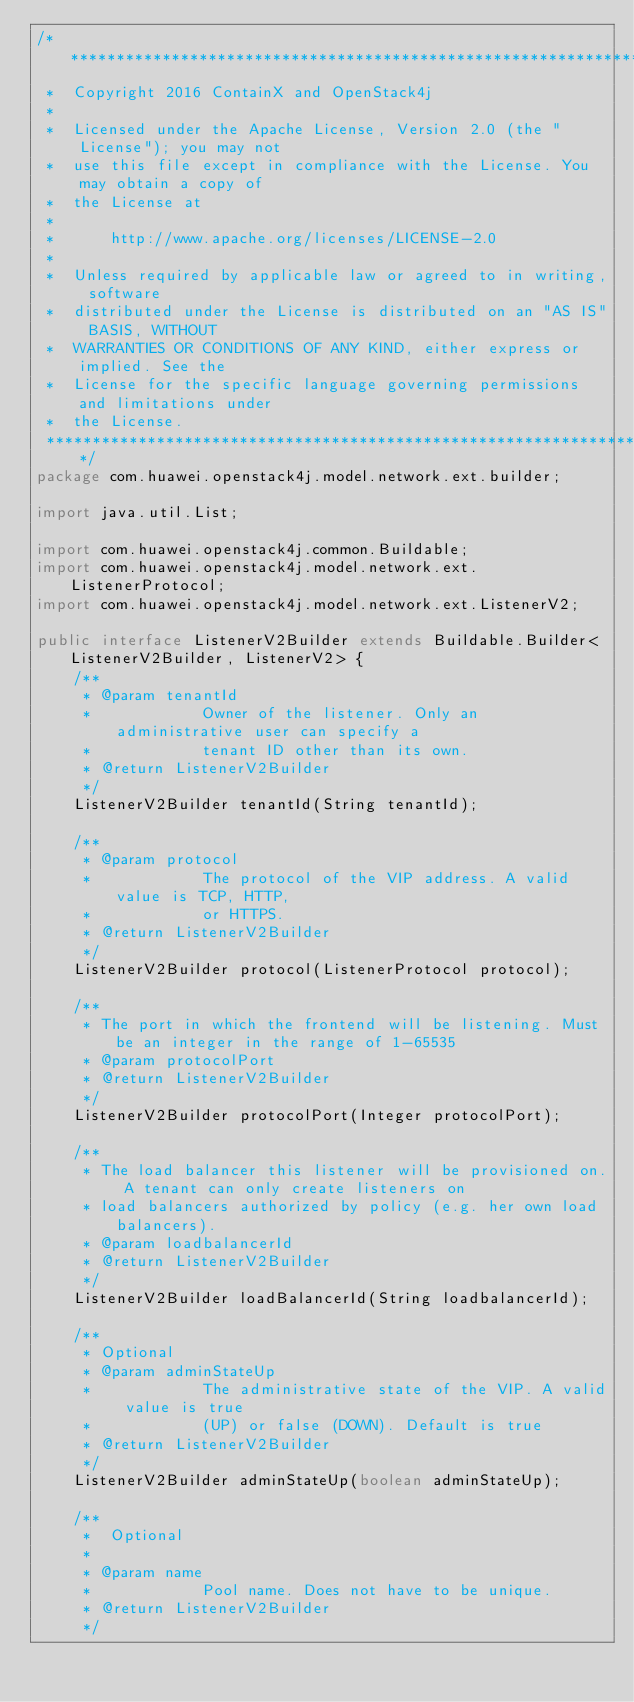Convert code to text. <code><loc_0><loc_0><loc_500><loc_500><_Java_>/*******************************************************************************
 * 	Copyright 2016 ContainX and OpenStack4j                                          
 * 	                                                                                 
 * 	Licensed under the Apache License, Version 2.0 (the "License"); you may not      
 * 	use this file except in compliance with the License. You may obtain a copy of    
 * 	the License at                                                                   
 * 	                                                                                 
 * 	    http://www.apache.org/licenses/LICENSE-2.0                                   
 * 	                                                                                 
 * 	Unless required by applicable law or agreed to in writing, software              
 * 	distributed under the License is distributed on an "AS IS" BASIS, WITHOUT        
 * 	WARRANTIES OR CONDITIONS OF ANY KIND, either express or implied. See the         
 * 	License for the specific language governing permissions and limitations under    
 * 	the License.                                                                     
 *******************************************************************************/
package com.huawei.openstack4j.model.network.ext.builder;

import java.util.List;

import com.huawei.openstack4j.common.Buildable;
import com.huawei.openstack4j.model.network.ext.ListenerProtocol;
import com.huawei.openstack4j.model.network.ext.ListenerV2;

public interface ListenerV2Builder extends Buildable.Builder<ListenerV2Builder, ListenerV2> {
    /**
     * @param tenantId
     *            Owner of the listener. Only an administrative user can specify a
     *            tenant ID other than its own.
     * @return ListenerV2Builder
     */
    ListenerV2Builder tenantId(String tenantId);

    /**
     * @param protocol
     *            The protocol of the VIP address. A valid value is TCP, HTTP,
     *            or HTTPS.
     * @return ListenerV2Builder
     */
    ListenerV2Builder protocol(ListenerProtocol protocol);

    /**
     * The port in which the frontend will be listening. Must be an integer in the range of 1-65535
     * @param protocolPort
     * @return ListenerV2Builder
     */
    ListenerV2Builder protocolPort(Integer protocolPort);

    /**
     * The load balancer this listener will be provisioned on. A tenant can only create listeners on
     * load balancers authorized by policy (e.g. her own load balancers).
     * @param loadbalancerId
     * @return ListenerV2Builder
     */
    ListenerV2Builder loadBalancerId(String loadbalancerId);

    /**
     * Optional
     * @param adminStateUp
     *            The administrative state of the VIP. A valid value is true
     *            (UP) or false (DOWN). Default is true
     * @return ListenerV2Builder
     */
    ListenerV2Builder adminStateUp(boolean adminStateUp);

    /**
     *  Optional
     *
     * @param name
     *            Pool name. Does not have to be unique.
     * @return ListenerV2Builder
     */</code> 